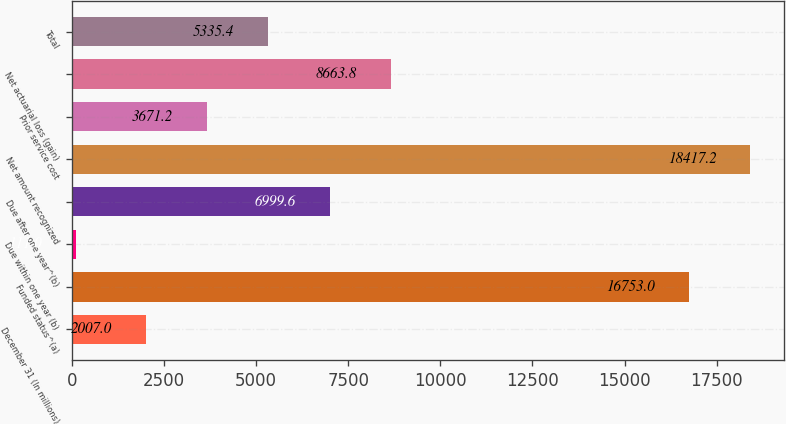Convert chart to OTSL. <chart><loc_0><loc_0><loc_500><loc_500><bar_chart><fcel>December 31 (In millions)<fcel>Funded status^(a)<fcel>Due within one year (b)<fcel>Due after one year^(b)<fcel>Net amount recognized<fcel>Prior service cost<fcel>Net actuarial loss (gain)<fcel>Total<nl><fcel>2007<fcel>16753<fcel>111<fcel>6999.6<fcel>18417.2<fcel>3671.2<fcel>8663.8<fcel>5335.4<nl></chart> 